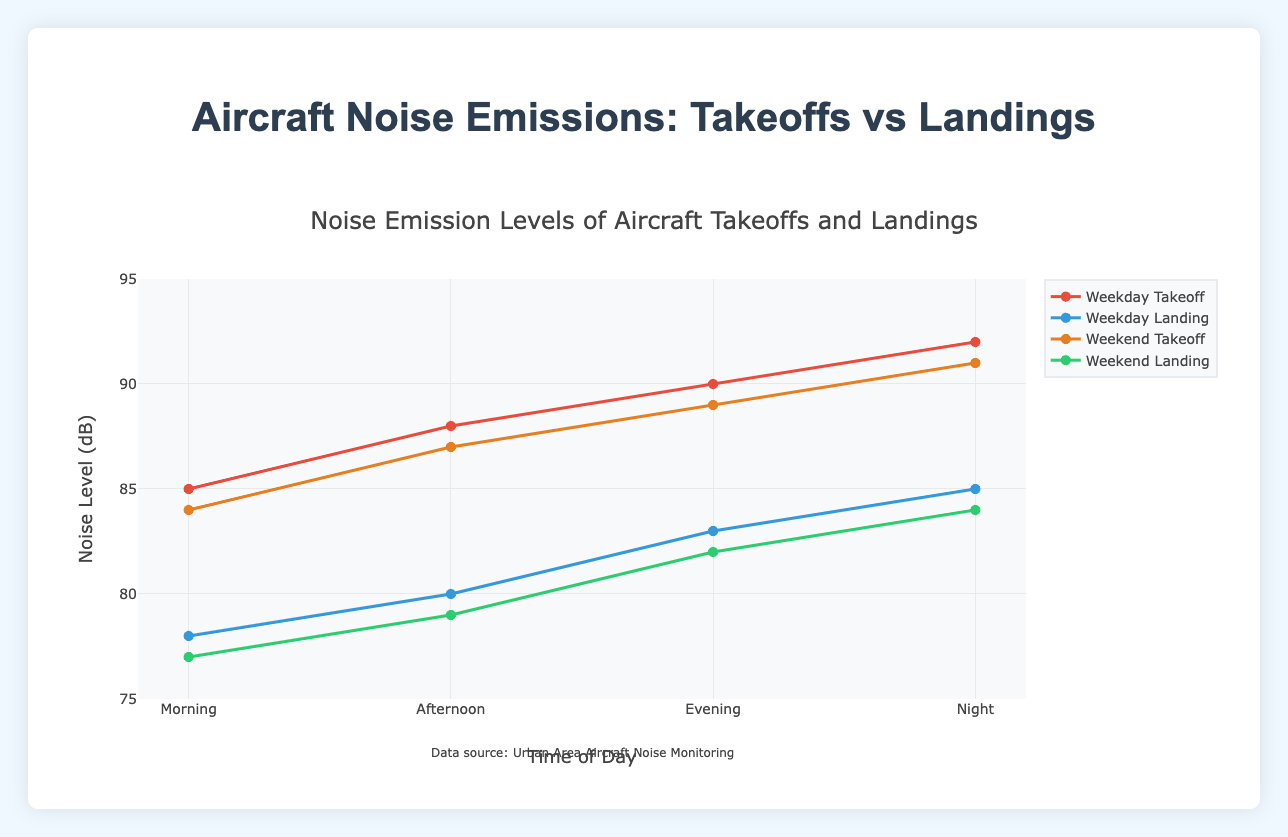What is the general trend in noise levels from morning to night for weekday takeoffs? The noise levels for weekday takeoffs increase steadily from morning (85 dB) to night (92 dB), indicating a progressive rise in noise emissions throughout the day.
Answer: Increasing trend Which time of day experiences the highest noise level for weekend landings? By observing the weekend landing noise levels across the times of day, the night has the highest level at 84 dB.
Answer: Night How does the weekend afternoon takeoff noise level compare with that of the weekday afternoon takeoff? Comparing the afternoon takeoff noise levels, the weekend is 87 dB and the weekday is 88 dB, so the weekend is 1 dB lower.
Answer: 1 dB lower Is there a significant difference between weekday and weekend landing noise levels in the evening? The evening landing noise levels for weekdays and weekends are 83 dB and 82 dB respectively, with only a 1 dB difference, implying they are quite similar.
Answer: 1 dB difference What is the average noise level of weekend takeoffs across all times of the day? To find the average: (84 + 87 + 89 + 91) / 4 = 351 / 4, which equals 87.75 dB.
Answer: 87.75 dB Which has higher noise emission on average, weekday or weekend landings? Calculate the averages: 
Weekday: (78 + 80 + 83 + 85) / 4 = 326 / 4 = 81.5 dB 
Weekend: (77 + 79 + 82 + 84) / 4 = 322 / 4 = 80.5 dB 
Weekdays are higher by 1 dB on average.
Answer: Weekdays Compare takeoff noise levels between weekday and weekend evenings. The evening takeoff noise levels are 90 dB on weekdays and 89 dB on weekends, showing that weekdays are slightly higher by 1 dB.
Answer: Weekdays higher by 1 dB How does morning noise level for weekday takeoffs compare to their respective landings? The morning takeoff noise level is 85 dB, while the landing noise level is 78 dB, resulting in a difference of 7 dB with takeoffs being louder.
Answer: Takeoffs 7 dB louder What is the total sum of noise levels for weekend landings throughout the day? Sum up all the weekend landing noise levels: 77 + 79 + 82 + 84 = 322 dB in total.
Answer: 322 dB In terms of visual color coding, which plot line corresponds to the highest noise levels at night? The highest noise levels at night are from the weekday takeoffs (92 dB), which is represented by the red line on the plot.
Answer: Red line 